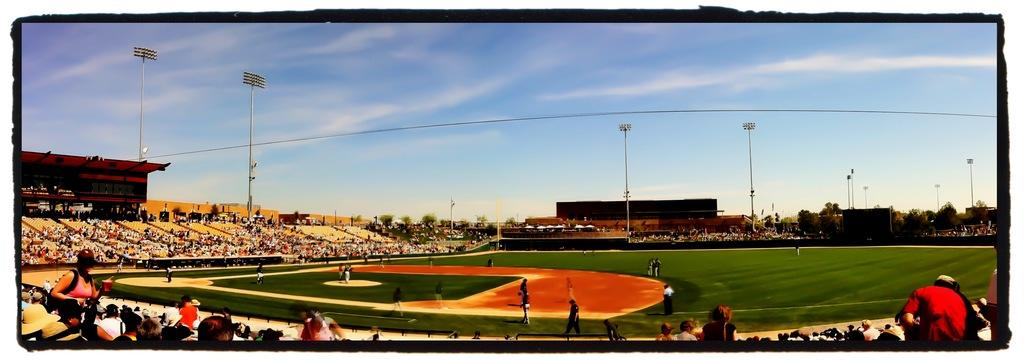What can be seen in the sky in the image? The sky is visible in the image, but no specific details about the sky are mentioned in the facts. What is visible at ground level in the image? The ground is visible in the image. What are the people in the image doing? The people in the image are sitting. What type of vegetation is present in the image? Trees are present in the image. What can be seen illuminated in the image? Lights are visible in the image. What type of structure is present in the image? There is a building in the image. What type of slope can be seen in the image? There is no mention of a slope in the image, so it cannot be determined from the facts. What adjustments are being made to the building in the image? There is no indication of any adjustments being made to the building in the image. 